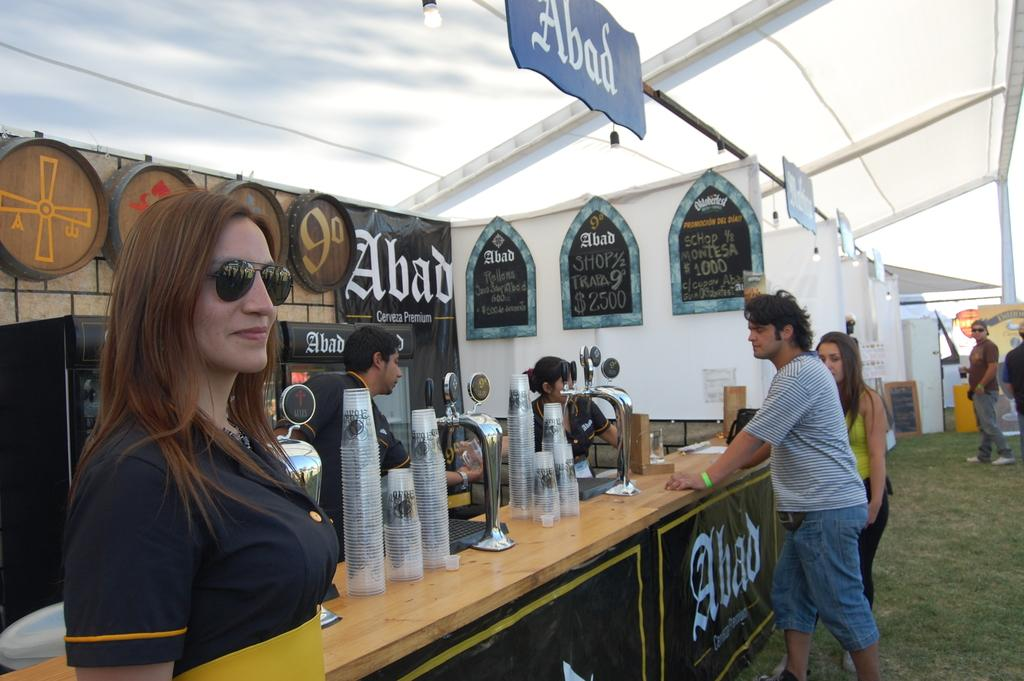Who or what can be seen in the image? There are people in the image. What is on the table in the image? There are objects on a table in the image. What type of items have text on them in the image? There are boards with text in the image. What can be seen illuminating the scene in the image? There is a light visible at the top of the image. How many bikes are parked next to the people in the image? There are no bikes present in the image. 